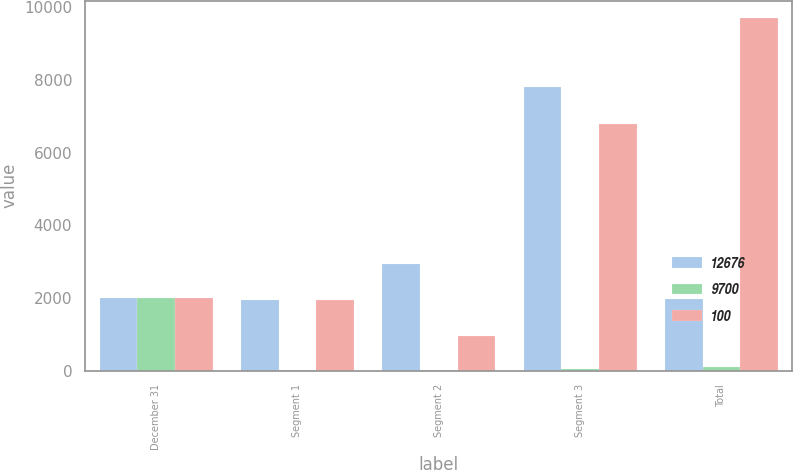Convert chart. <chart><loc_0><loc_0><loc_500><loc_500><stacked_bar_chart><ecel><fcel>December 31<fcel>Segment 1<fcel>Segment 2<fcel>Segment 3<fcel>Total<nl><fcel>12676<fcel>2008<fcel>1940<fcel>2930<fcel>7806<fcel>1973.5<nl><fcel>9700<fcel>2008<fcel>15<fcel>23<fcel>62<fcel>100<nl><fcel>100<fcel>2007<fcel>1940<fcel>970<fcel>6790<fcel>9700<nl></chart> 